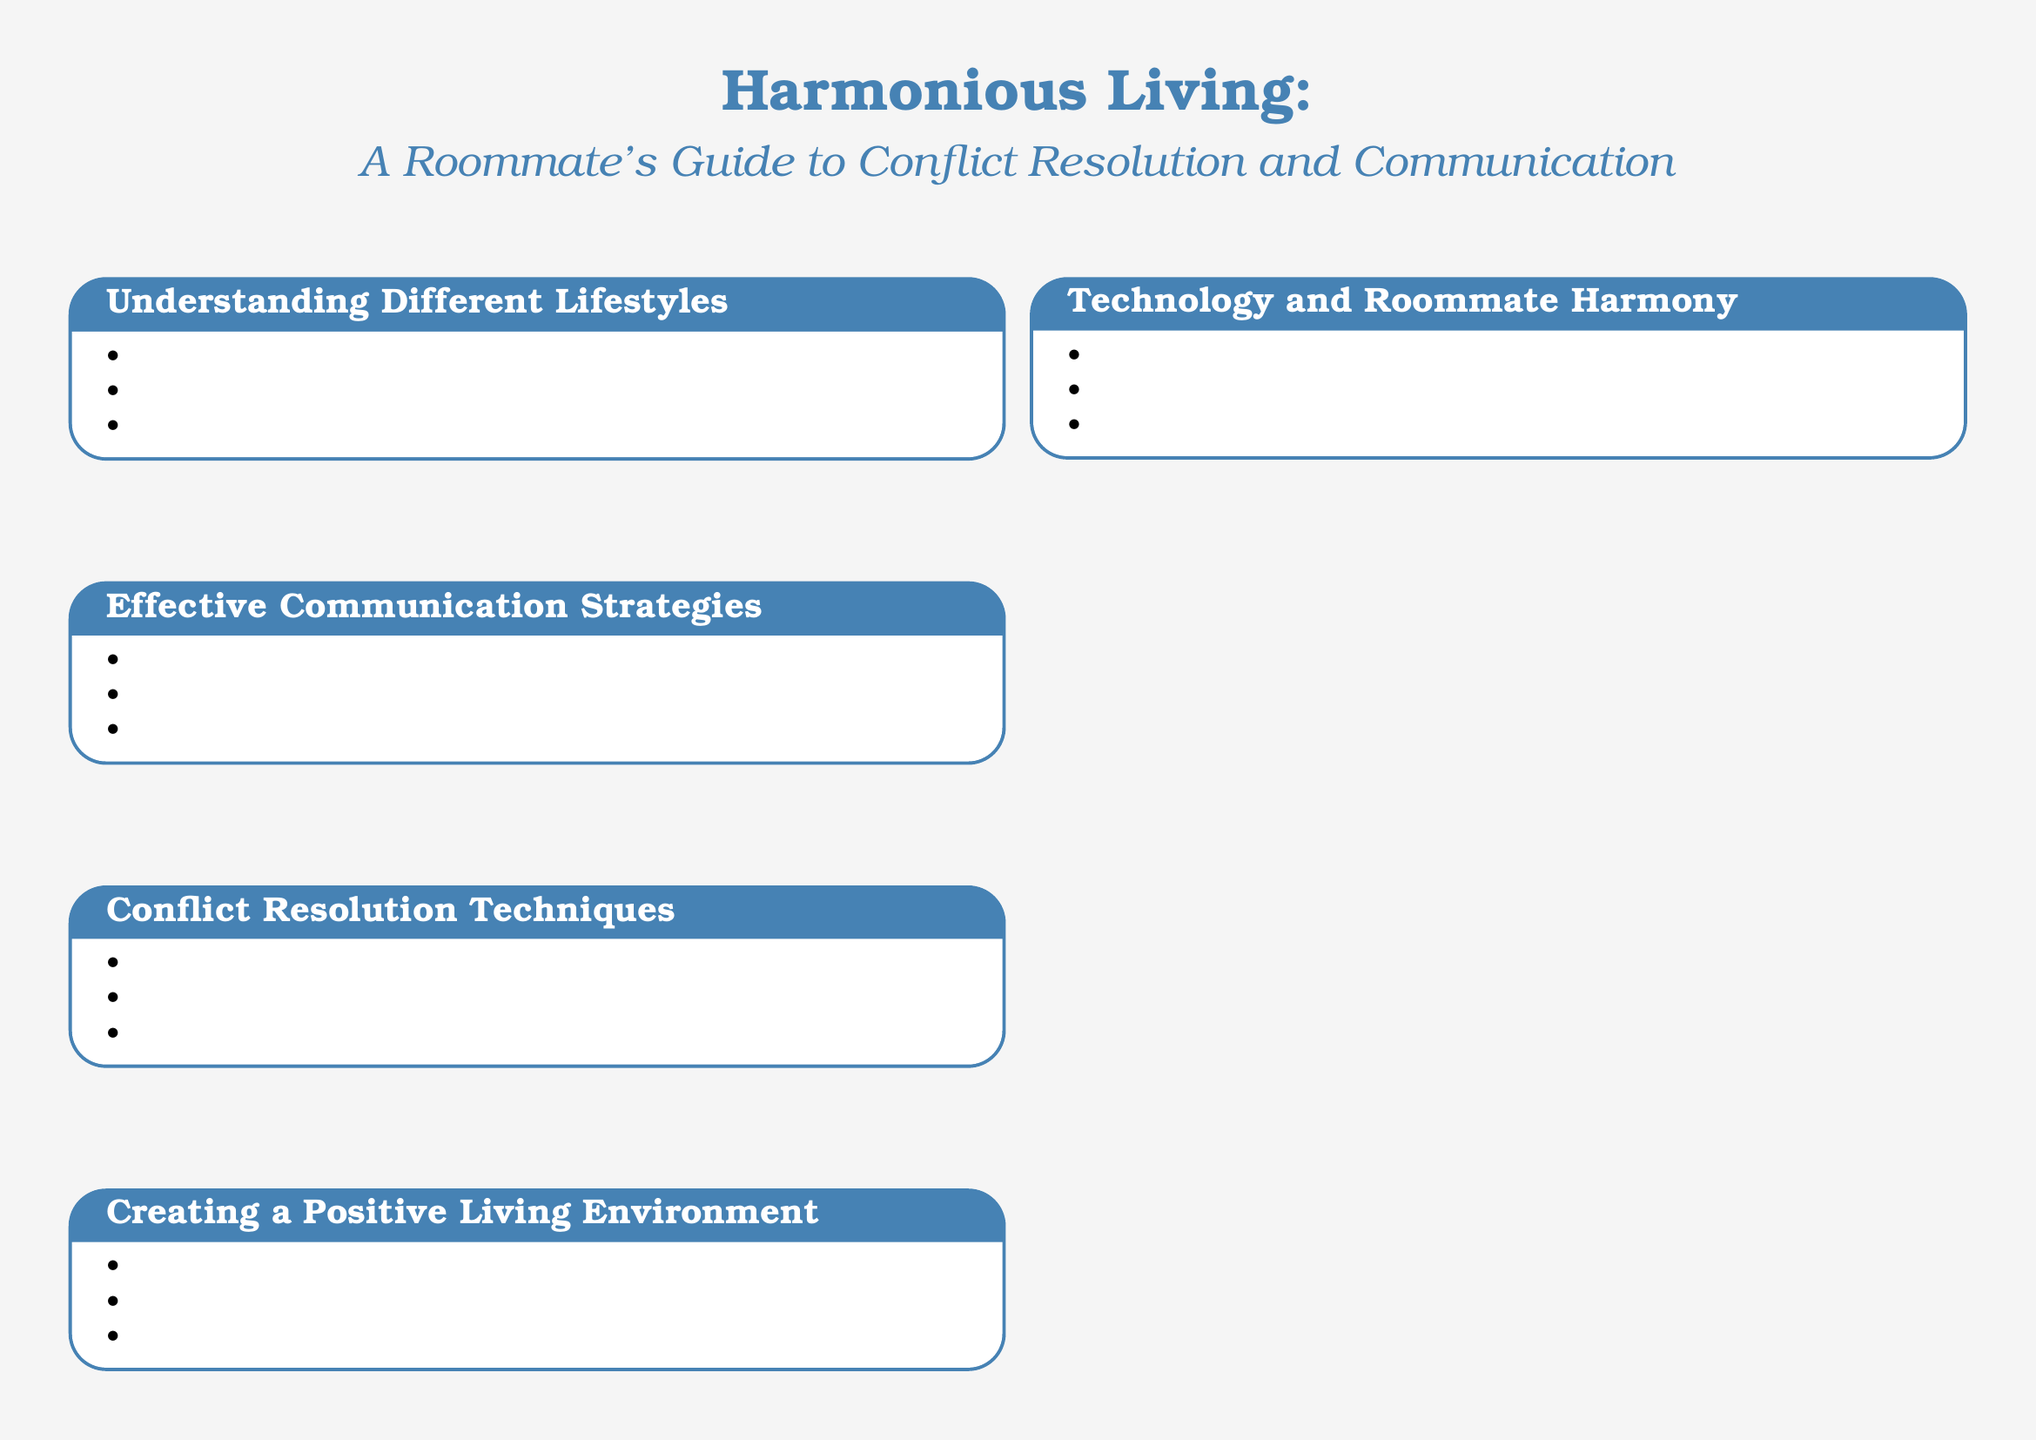What is the title of the document? The title of the document is presented prominently at the top, stating the purpose of the guide.
Answer: Harmonious Living: A Roommate's Guide to Conflict Resolution and Communication How many sections are there in the guide? The guide contains a list of five sections that address various aspects of living harmoniously with roommates.
Answer: Five What is one of the recommended resources? The document lists resources that can help roommates navigate their living situation, including books and websites.
Answer: The Roommate Survival Guide by Lisa Mirza Grotts What technique is suggested for expressing concerns? One specific communication strategy is highlighted as a way to communicate effectively between roommates.
Answer: Using 'I' statements to express concerns What is the focus of the section titled "Creating a Positive Living Environment"? This section emphasizes principles and practices that can help create a harmonious living situation among roommates.
Answer: Establishing clear house rules and boundaries What should roommates do to resolve conflicts? The document advises a systematic approach for resolving disagreements among roommates.
Answer: Compromise and finding win-win solutions What is one tip for tolerant roommates? The guide includes practical advice on how roommates can better support each other in their living environment.
Answer: Lead by example in showing consideration for others 